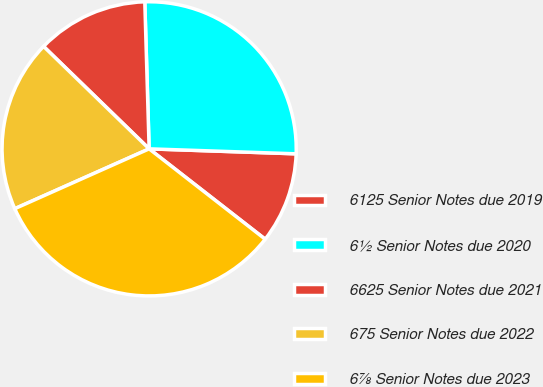Convert chart. <chart><loc_0><loc_0><loc_500><loc_500><pie_chart><fcel>6125 Senior Notes due 2019<fcel>6½ Senior Notes due 2020<fcel>6625 Senior Notes due 2021<fcel>675 Senior Notes due 2022<fcel>6⅞ Senior Notes due 2023<nl><fcel>9.99%<fcel>26.01%<fcel>12.27%<fcel>18.93%<fcel>32.8%<nl></chart> 